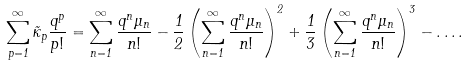<formula> <loc_0><loc_0><loc_500><loc_500>\sum _ { p = 1 } ^ { \infty } \tilde { \kappa } _ { p } \frac { q ^ { p } } { p ! } = \sum _ { n = 1 } ^ { \infty } \frac { q ^ { n } \mu _ { n } } { n ! } - \frac { 1 } { 2 } \left ( \sum _ { n = 1 } ^ { \infty } \frac { q ^ { n } \mu _ { n } } { n ! } \right ) ^ { 2 } + \frac { 1 } { 3 } \left ( \sum _ { n = 1 } ^ { \infty } \frac { q ^ { n } \mu _ { n } } { n ! } \right ) ^ { 3 } - \dots .</formula> 